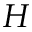Convert formula to latex. <formula><loc_0><loc_0><loc_500><loc_500>H</formula> 